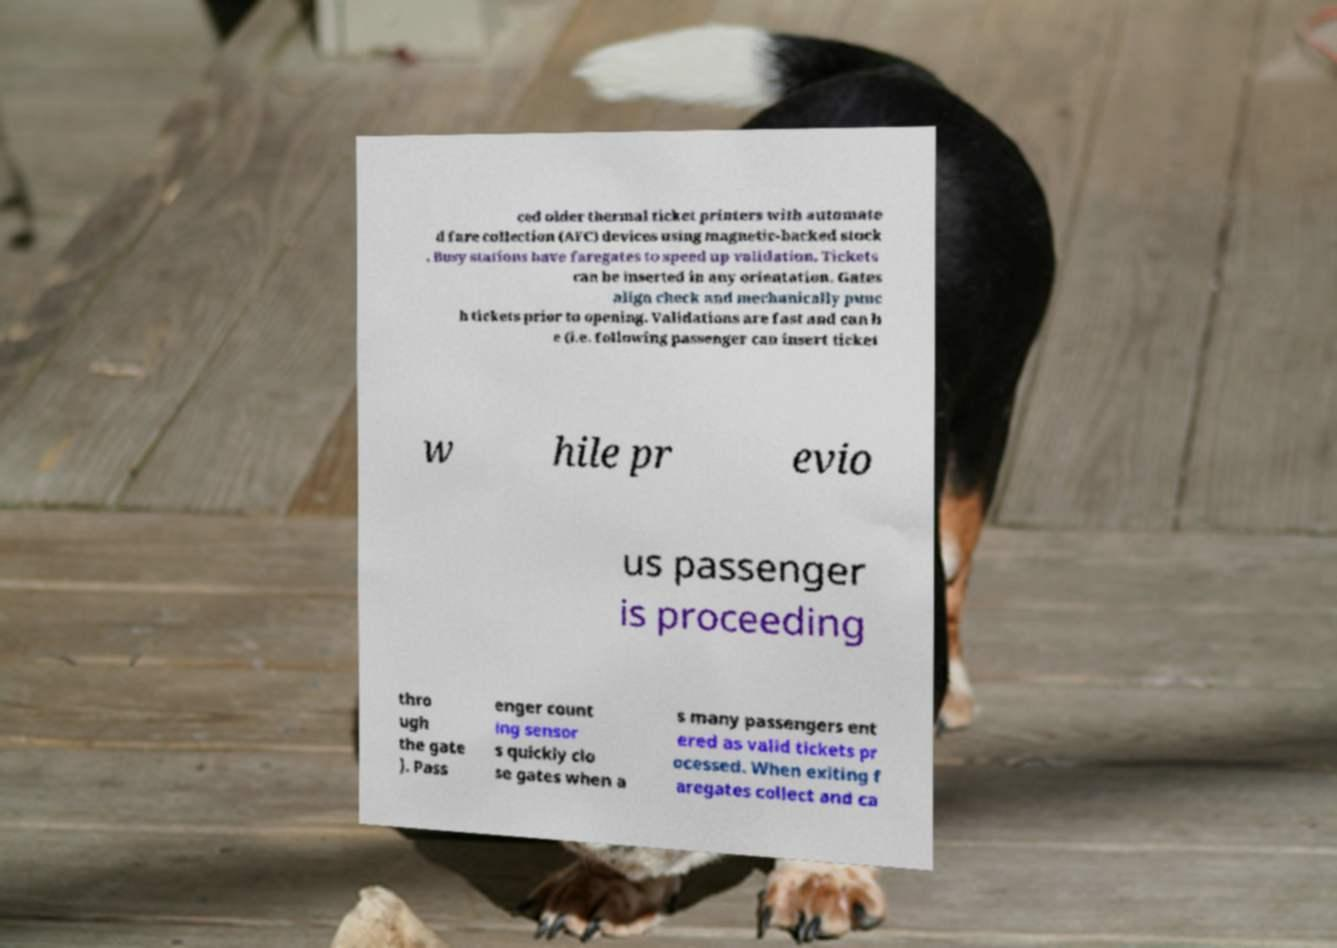Can you read and provide the text displayed in the image?This photo seems to have some interesting text. Can you extract and type it out for me? ced older thermal ticket printers with automate d fare collection (AFC) devices using magnetic-backed stock . Busy stations have faregates to speed up validation. Tickets can be inserted in any orientation. Gates align check and mechanically punc h tickets prior to opening. Validations are fast and can b e (i.e. following passenger can insert ticket w hile pr evio us passenger is proceeding thro ugh the gate ). Pass enger count ing sensor s quickly clo se gates when a s many passengers ent ered as valid tickets pr ocessed. When exiting f aregates collect and ca 